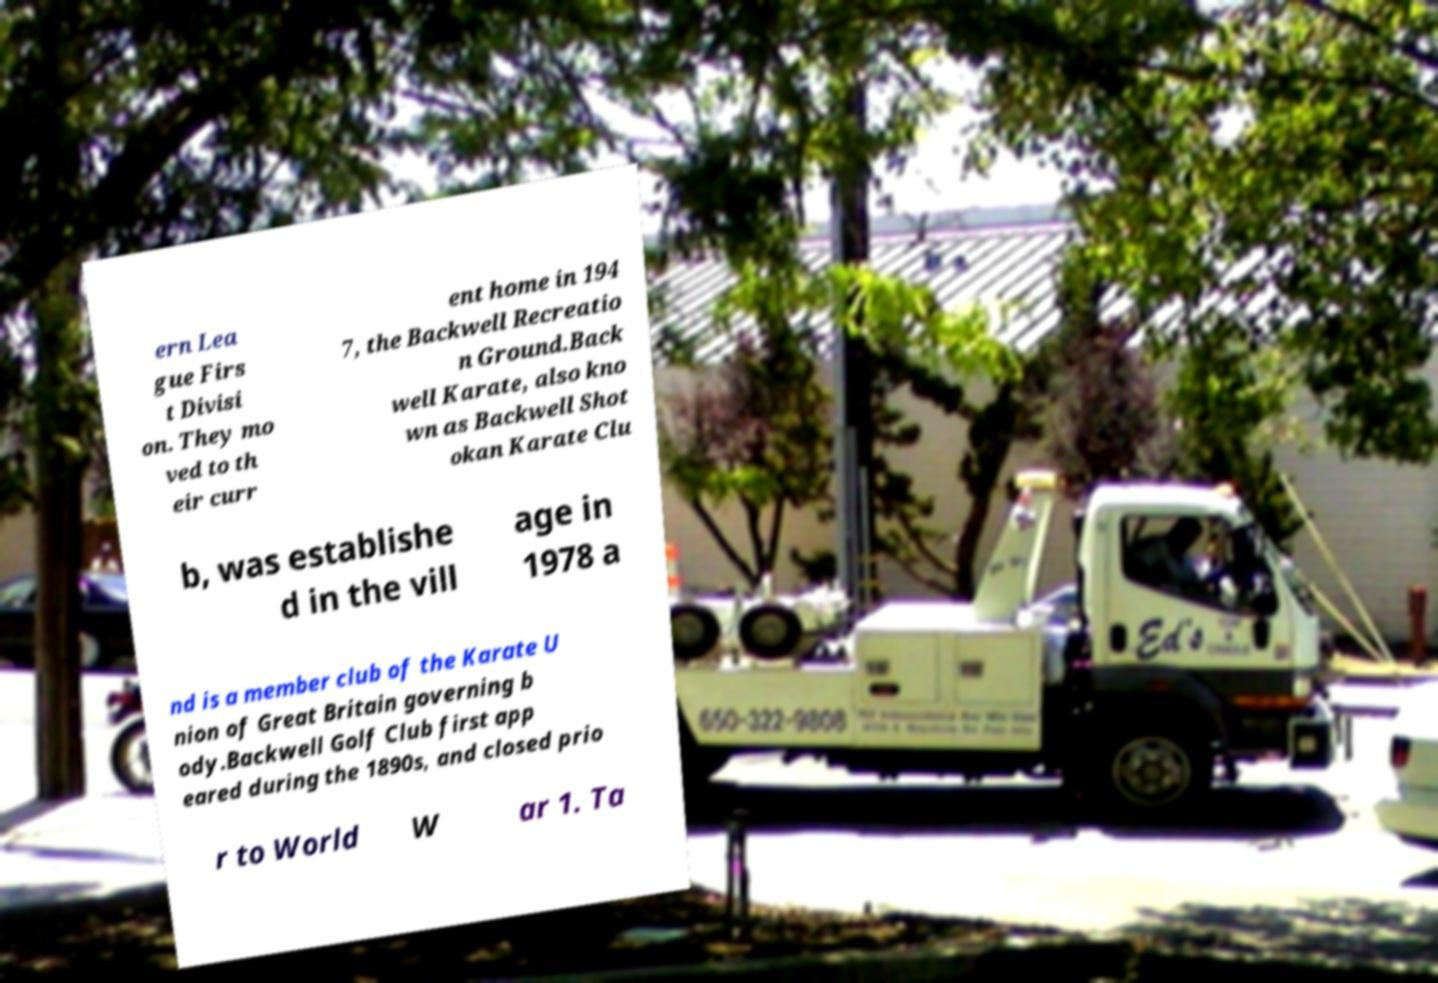Can you read and provide the text displayed in the image?This photo seems to have some interesting text. Can you extract and type it out for me? ern Lea gue Firs t Divisi on. They mo ved to th eir curr ent home in 194 7, the Backwell Recreatio n Ground.Back well Karate, also kno wn as Backwell Shot okan Karate Clu b, was establishe d in the vill age in 1978 a nd is a member club of the Karate U nion of Great Britain governing b ody.Backwell Golf Club first app eared during the 1890s, and closed prio r to World W ar 1. Ta 